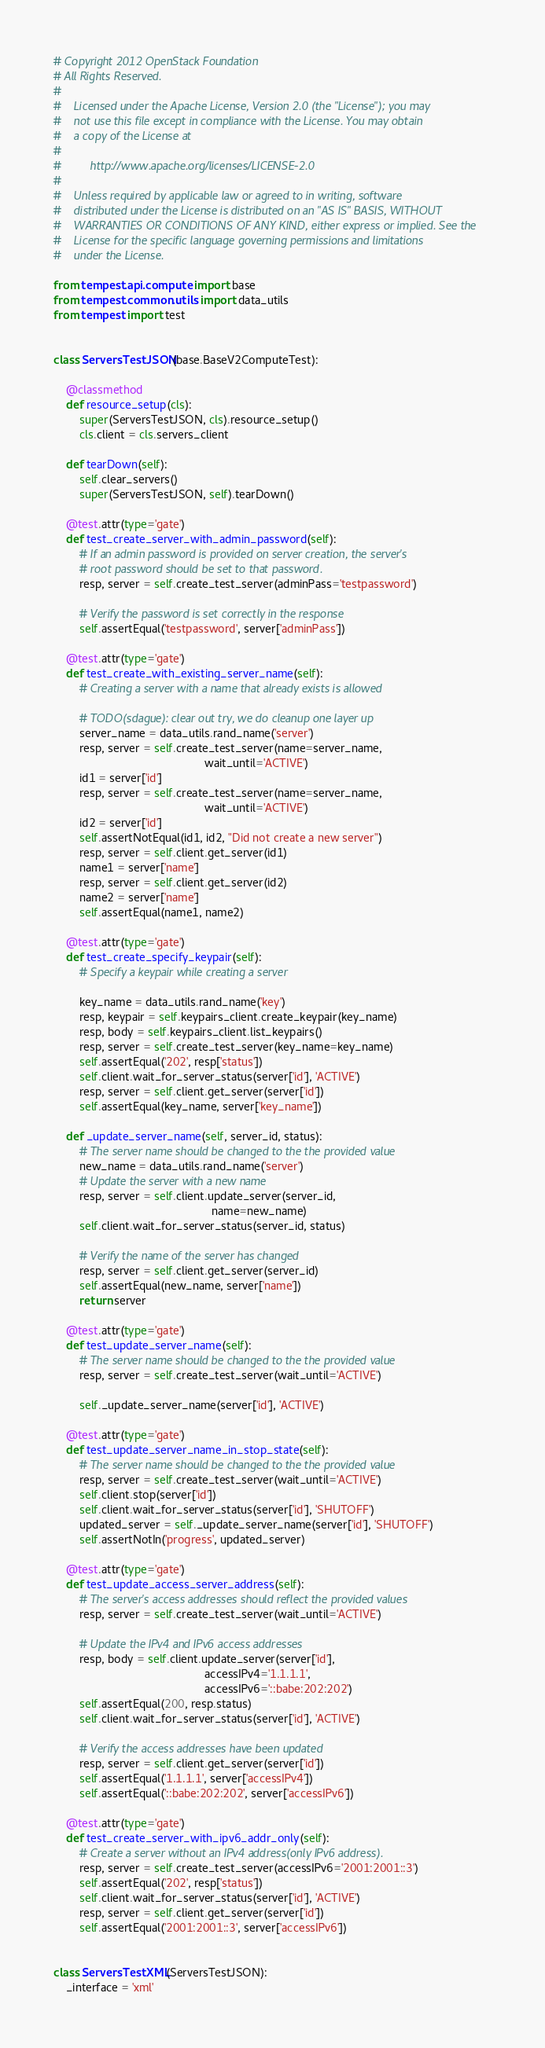Convert code to text. <code><loc_0><loc_0><loc_500><loc_500><_Python_># Copyright 2012 OpenStack Foundation
# All Rights Reserved.
#
#    Licensed under the Apache License, Version 2.0 (the "License"); you may
#    not use this file except in compliance with the License. You may obtain
#    a copy of the License at
#
#         http://www.apache.org/licenses/LICENSE-2.0
#
#    Unless required by applicable law or agreed to in writing, software
#    distributed under the License is distributed on an "AS IS" BASIS, WITHOUT
#    WARRANTIES OR CONDITIONS OF ANY KIND, either express or implied. See the
#    License for the specific language governing permissions and limitations
#    under the License.

from tempest.api.compute import base
from tempest.common.utils import data_utils
from tempest import test


class ServersTestJSON(base.BaseV2ComputeTest):

    @classmethod
    def resource_setup(cls):
        super(ServersTestJSON, cls).resource_setup()
        cls.client = cls.servers_client

    def tearDown(self):
        self.clear_servers()
        super(ServersTestJSON, self).tearDown()

    @test.attr(type='gate')
    def test_create_server_with_admin_password(self):
        # If an admin password is provided on server creation, the server's
        # root password should be set to that password.
        resp, server = self.create_test_server(adminPass='testpassword')

        # Verify the password is set correctly in the response
        self.assertEqual('testpassword', server['adminPass'])

    @test.attr(type='gate')
    def test_create_with_existing_server_name(self):
        # Creating a server with a name that already exists is allowed

        # TODO(sdague): clear out try, we do cleanup one layer up
        server_name = data_utils.rand_name('server')
        resp, server = self.create_test_server(name=server_name,
                                               wait_until='ACTIVE')
        id1 = server['id']
        resp, server = self.create_test_server(name=server_name,
                                               wait_until='ACTIVE')
        id2 = server['id']
        self.assertNotEqual(id1, id2, "Did not create a new server")
        resp, server = self.client.get_server(id1)
        name1 = server['name']
        resp, server = self.client.get_server(id2)
        name2 = server['name']
        self.assertEqual(name1, name2)

    @test.attr(type='gate')
    def test_create_specify_keypair(self):
        # Specify a keypair while creating a server

        key_name = data_utils.rand_name('key')
        resp, keypair = self.keypairs_client.create_keypair(key_name)
        resp, body = self.keypairs_client.list_keypairs()
        resp, server = self.create_test_server(key_name=key_name)
        self.assertEqual('202', resp['status'])
        self.client.wait_for_server_status(server['id'], 'ACTIVE')
        resp, server = self.client.get_server(server['id'])
        self.assertEqual(key_name, server['key_name'])

    def _update_server_name(self, server_id, status):
        # The server name should be changed to the the provided value
        new_name = data_utils.rand_name('server')
        # Update the server with a new name
        resp, server = self.client.update_server(server_id,
                                                 name=new_name)
        self.client.wait_for_server_status(server_id, status)

        # Verify the name of the server has changed
        resp, server = self.client.get_server(server_id)
        self.assertEqual(new_name, server['name'])
        return server

    @test.attr(type='gate')
    def test_update_server_name(self):
        # The server name should be changed to the the provided value
        resp, server = self.create_test_server(wait_until='ACTIVE')

        self._update_server_name(server['id'], 'ACTIVE')

    @test.attr(type='gate')
    def test_update_server_name_in_stop_state(self):
        # The server name should be changed to the the provided value
        resp, server = self.create_test_server(wait_until='ACTIVE')
        self.client.stop(server['id'])
        self.client.wait_for_server_status(server['id'], 'SHUTOFF')
        updated_server = self._update_server_name(server['id'], 'SHUTOFF')
        self.assertNotIn('progress', updated_server)

    @test.attr(type='gate')
    def test_update_access_server_address(self):
        # The server's access addresses should reflect the provided values
        resp, server = self.create_test_server(wait_until='ACTIVE')

        # Update the IPv4 and IPv6 access addresses
        resp, body = self.client.update_server(server['id'],
                                               accessIPv4='1.1.1.1',
                                               accessIPv6='::babe:202:202')
        self.assertEqual(200, resp.status)
        self.client.wait_for_server_status(server['id'], 'ACTIVE')

        # Verify the access addresses have been updated
        resp, server = self.client.get_server(server['id'])
        self.assertEqual('1.1.1.1', server['accessIPv4'])
        self.assertEqual('::babe:202:202', server['accessIPv6'])

    @test.attr(type='gate')
    def test_create_server_with_ipv6_addr_only(self):
        # Create a server without an IPv4 address(only IPv6 address).
        resp, server = self.create_test_server(accessIPv6='2001:2001::3')
        self.assertEqual('202', resp['status'])
        self.client.wait_for_server_status(server['id'], 'ACTIVE')
        resp, server = self.client.get_server(server['id'])
        self.assertEqual('2001:2001::3', server['accessIPv6'])


class ServersTestXML(ServersTestJSON):
    _interface = 'xml'
</code> 